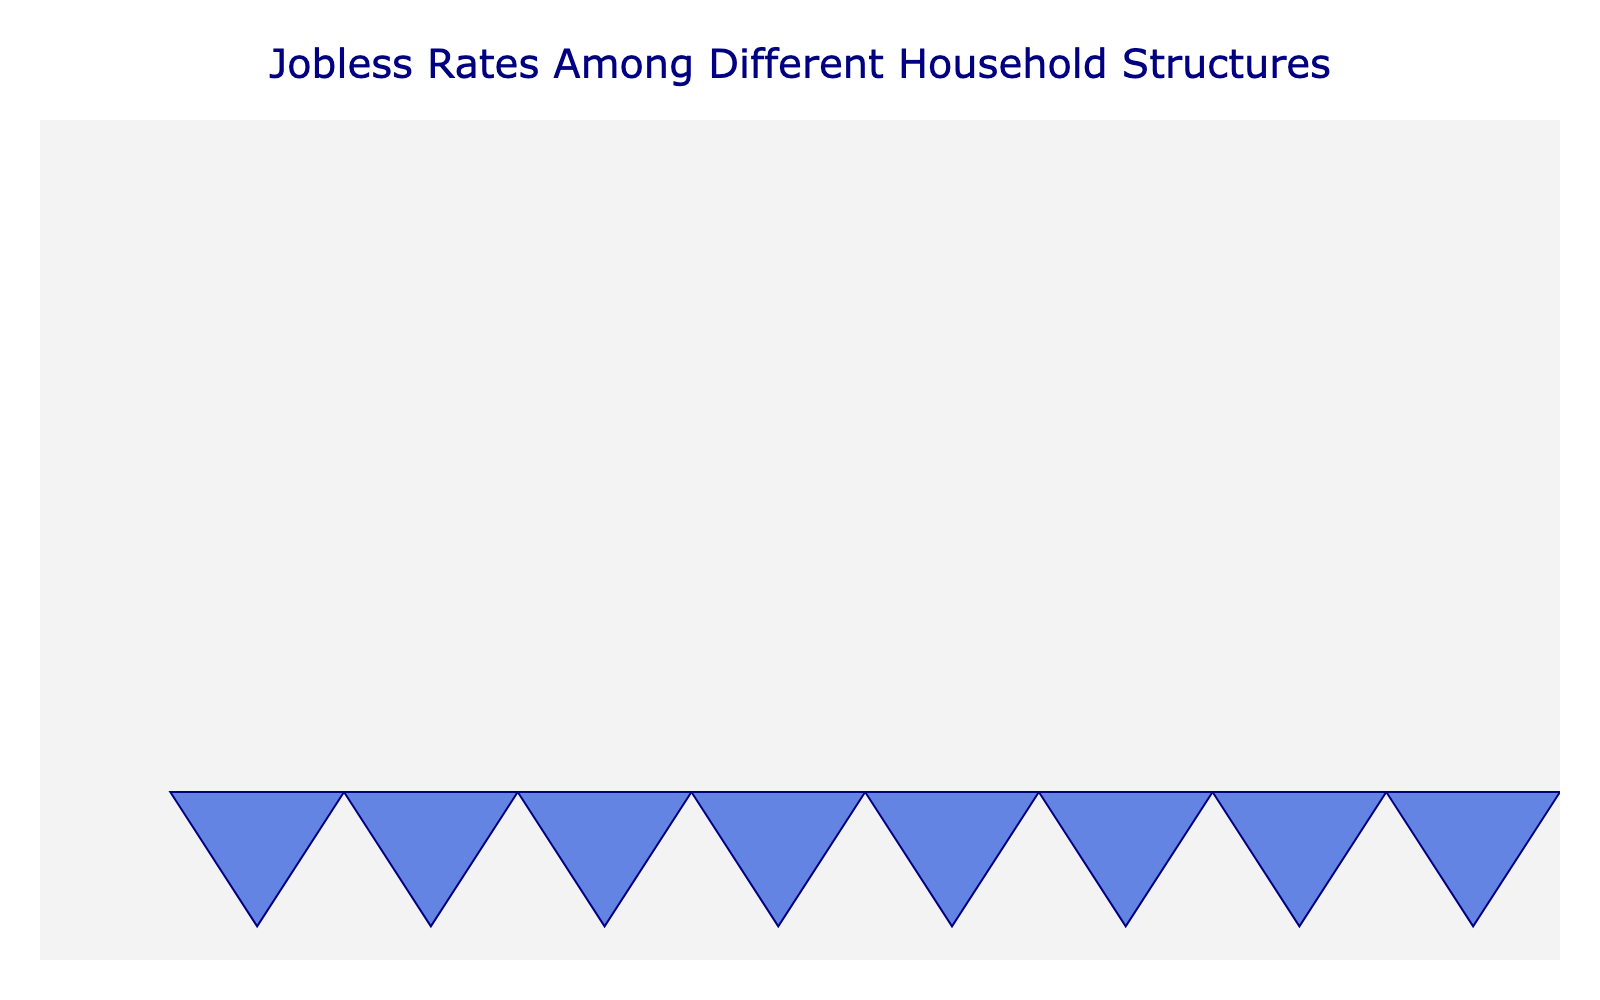What is the title of the plot? The title is located at the top of the figure and is usually the most prominent text.
Answer: Jobless Rates Among Different Household Structures How many icons are there for Single Parent households? Each icon in the plot represents one unit of the jobless rate. Count the icons next to "Single Parent" to find the number.
Answer: 18 Which household type has the lowest jobless rate? Identify the label with the smallest number of icons next to it in the plot.
Answer: Multigenerational What is the jobless rate for households headed by a Single Individual? Look for the label "Single Individual" in the plot and count the icons or refer to the annotated jobless rate.
Answer: 12% How do the jobless rates of Two-parent families and Cohabiting couples compare? Identify both household types in the plot, compare the number of icons next to them, and note the annotated jobless rate.
Answer: Cohabiting couples have a higher jobless rate at 11% compared to 9% for Two-parent families What is the average jobless rate of all household types combined? Sum the jobless rates of all household types and then divide by the number of household types.
Answer: (18+9+12+7+11)/5 = 11.4% How many household types have a jobless rate greater than 10%? Count the household types in the plot that have more than 10 icons or have their jobless rate annotated as greater than 10%.
Answer: 3 (Single Parent, Single Individual, Cohabiting couple) Which household type has a jobless rate exactly half that of Single Parent households? Determine half of the jobless rate of Single Parent (18/2 = 9) and find the household type(s) with a jobless rate of 9.
Answer: Two-parent family What is the difference in jobless rate between Single Individuals and Multigenerational households? Subtract the jobless rate of Multigenerational households from Single Individuals.
Answer: 12% - 7% = 5% Which household type has a jobless rate just above 10%? Identify the household type with a jobless rate slightly greater than 10% by comparing the annotated rates.
Answer: Cohabiting couples at 11% 